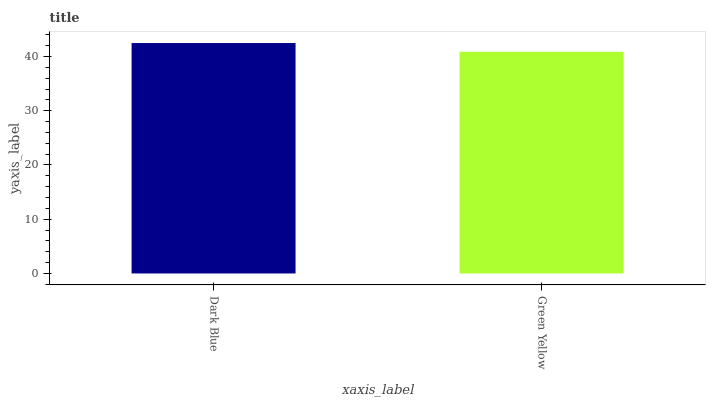Is Green Yellow the minimum?
Answer yes or no. Yes. Is Dark Blue the maximum?
Answer yes or no. Yes. Is Green Yellow the maximum?
Answer yes or no. No. Is Dark Blue greater than Green Yellow?
Answer yes or no. Yes. Is Green Yellow less than Dark Blue?
Answer yes or no. Yes. Is Green Yellow greater than Dark Blue?
Answer yes or no. No. Is Dark Blue less than Green Yellow?
Answer yes or no. No. Is Dark Blue the high median?
Answer yes or no. Yes. Is Green Yellow the low median?
Answer yes or no. Yes. Is Green Yellow the high median?
Answer yes or no. No. Is Dark Blue the low median?
Answer yes or no. No. 